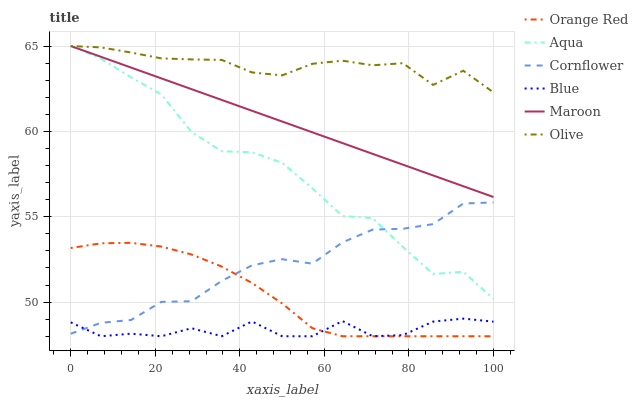Does Blue have the minimum area under the curve?
Answer yes or no. Yes. Does Olive have the maximum area under the curve?
Answer yes or no. Yes. Does Cornflower have the minimum area under the curve?
Answer yes or no. No. Does Cornflower have the maximum area under the curve?
Answer yes or no. No. Is Maroon the smoothest?
Answer yes or no. Yes. Is Blue the roughest?
Answer yes or no. Yes. Is Cornflower the smoothest?
Answer yes or no. No. Is Cornflower the roughest?
Answer yes or no. No. Does Cornflower have the lowest value?
Answer yes or no. No. Does Olive have the highest value?
Answer yes or no. Yes. Does Cornflower have the highest value?
Answer yes or no. No. Is Blue less than Maroon?
Answer yes or no. Yes. Is Maroon greater than Cornflower?
Answer yes or no. Yes. Does Cornflower intersect Aqua?
Answer yes or no. Yes. Is Cornflower less than Aqua?
Answer yes or no. No. Is Cornflower greater than Aqua?
Answer yes or no. No. Does Blue intersect Maroon?
Answer yes or no. No. 